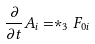Convert formula to latex. <formula><loc_0><loc_0><loc_500><loc_500>\frac { \partial } { \partial t } A _ { i } = \ast _ { 3 } F _ { 0 i }</formula> 